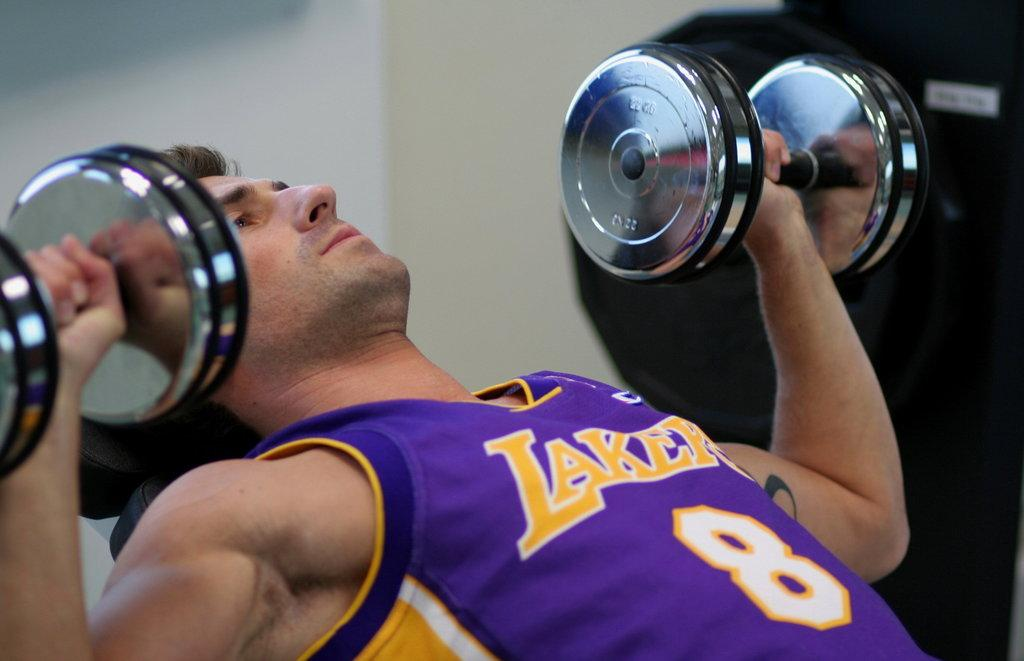<image>
Summarize the visual content of the image. A man in a purple Lakers top bearing the number 8 lifts weights. 